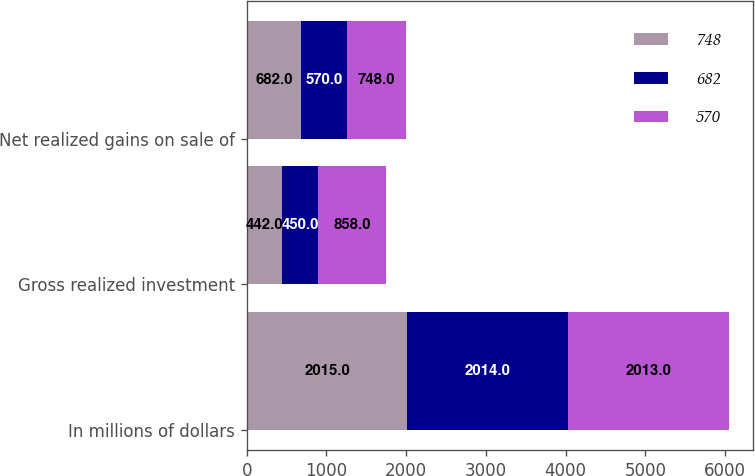Convert chart to OTSL. <chart><loc_0><loc_0><loc_500><loc_500><stacked_bar_chart><ecel><fcel>In millions of dollars<fcel>Gross realized investment<fcel>Net realized gains on sale of<nl><fcel>748<fcel>2015<fcel>442<fcel>682<nl><fcel>682<fcel>2014<fcel>450<fcel>570<nl><fcel>570<fcel>2013<fcel>858<fcel>748<nl></chart> 